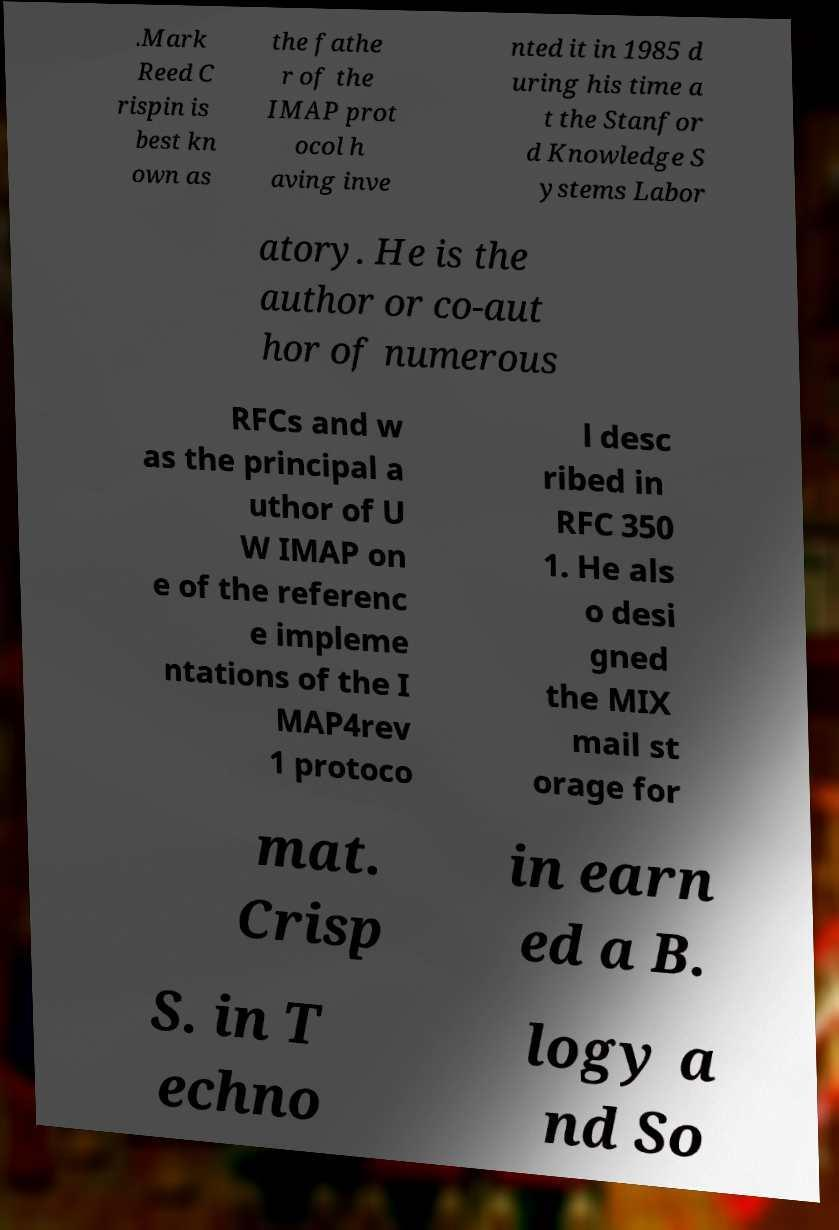For documentation purposes, I need the text within this image transcribed. Could you provide that? .Mark Reed C rispin is best kn own as the fathe r of the IMAP prot ocol h aving inve nted it in 1985 d uring his time a t the Stanfor d Knowledge S ystems Labor atory. He is the author or co-aut hor of numerous RFCs and w as the principal a uthor of U W IMAP on e of the referenc e impleme ntations of the I MAP4rev 1 protoco l desc ribed in RFC 350 1. He als o desi gned the MIX mail st orage for mat. Crisp in earn ed a B. S. in T echno logy a nd So 